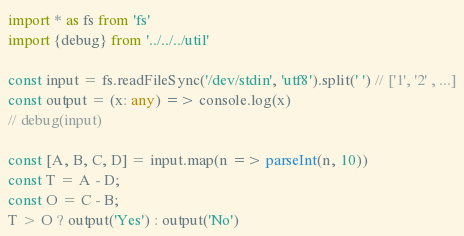<code> <loc_0><loc_0><loc_500><loc_500><_TypeScript_>import * as fs from 'fs'
import {debug} from '../../../util'

const input = fs.readFileSync('/dev/stdin', 'utf8').split(' ') // ['1', '2' , ...]
const output = (x: any) => console.log(x)
// debug(input)

const [A, B, C, D] = input.map(n => parseInt(n, 10))
const T = A - D;
const O = C - B;
T > O ? output('Yes') : output('No')</code> 